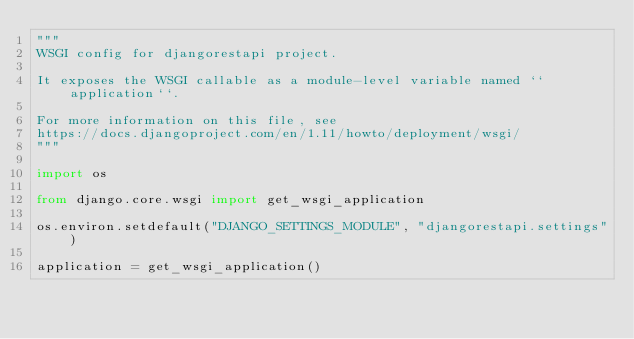<code> <loc_0><loc_0><loc_500><loc_500><_Python_>"""
WSGI config for djangorestapi project.

It exposes the WSGI callable as a module-level variable named ``application``.

For more information on this file, see
https://docs.djangoproject.com/en/1.11/howto/deployment/wsgi/
"""

import os

from django.core.wsgi import get_wsgi_application

os.environ.setdefault("DJANGO_SETTINGS_MODULE", "djangorestapi.settings")

application = get_wsgi_application()
</code> 